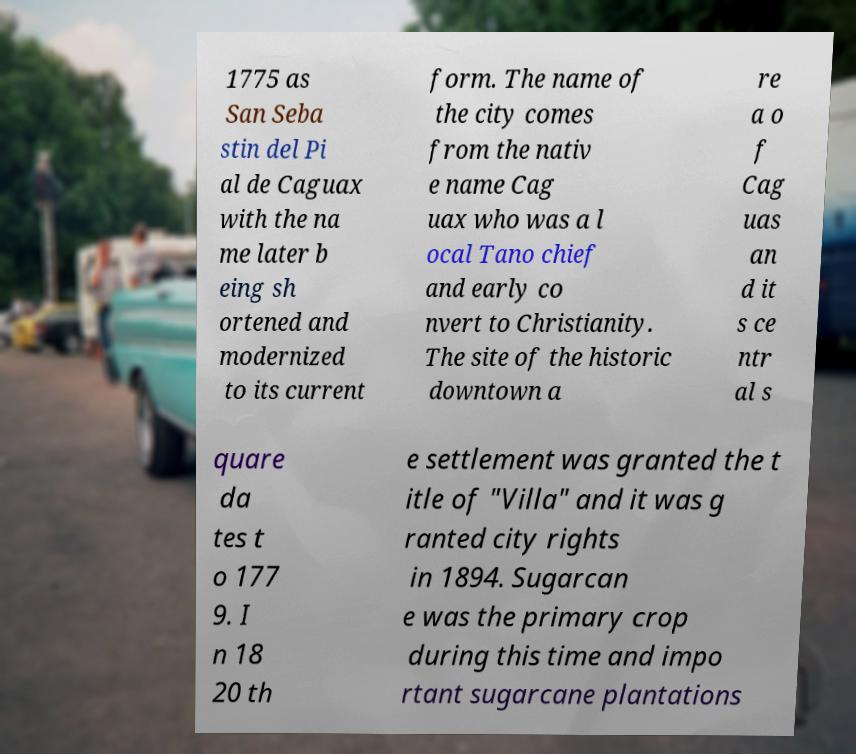Please read and relay the text visible in this image. What does it say? 1775 as San Seba stin del Pi al de Caguax with the na me later b eing sh ortened and modernized to its current form. The name of the city comes from the nativ e name Cag uax who was a l ocal Tano chief and early co nvert to Christianity. The site of the historic downtown a re a o f Cag uas an d it s ce ntr al s quare da tes t o 177 9. I n 18 20 th e settlement was granted the t itle of "Villa" and it was g ranted city rights in 1894. Sugarcan e was the primary crop during this time and impo rtant sugarcane plantations 